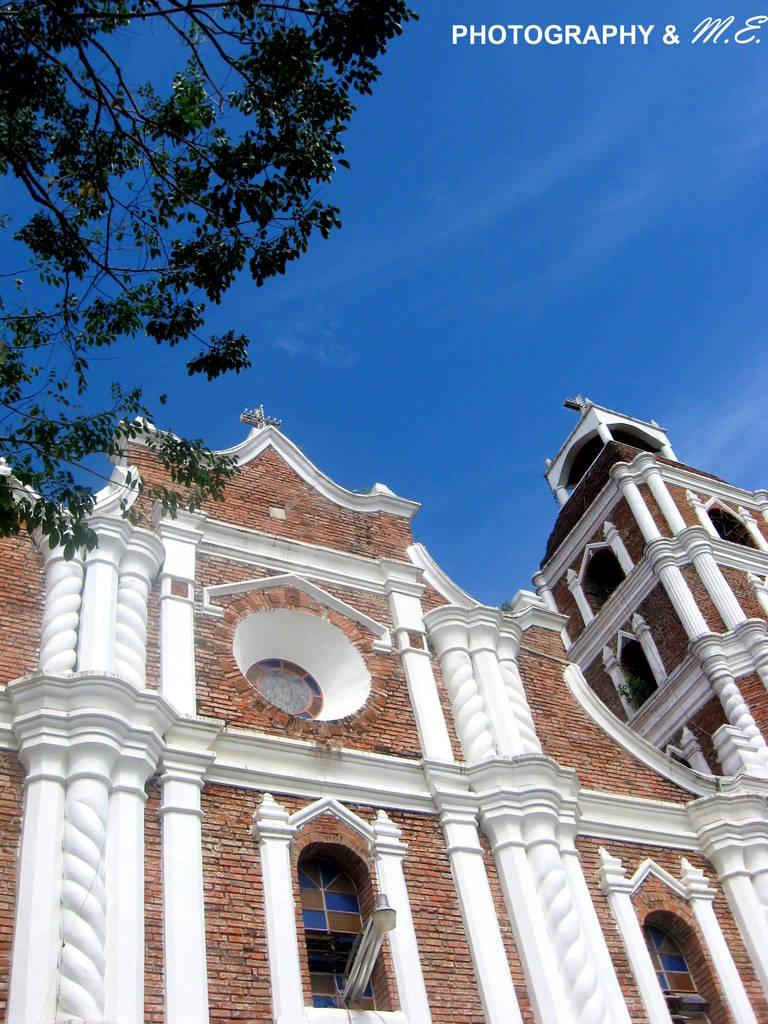What type of structures can be seen in the image? There are buildings in the image. What natural element is present in the image? There is a tree in the image. What color is the sky in the image? The sky is blue in the image. Where is the text located in the image? The text is at the top right corner of the image. How much of the substance is visible in the image? There is no substance mentioned or visible in the image. 